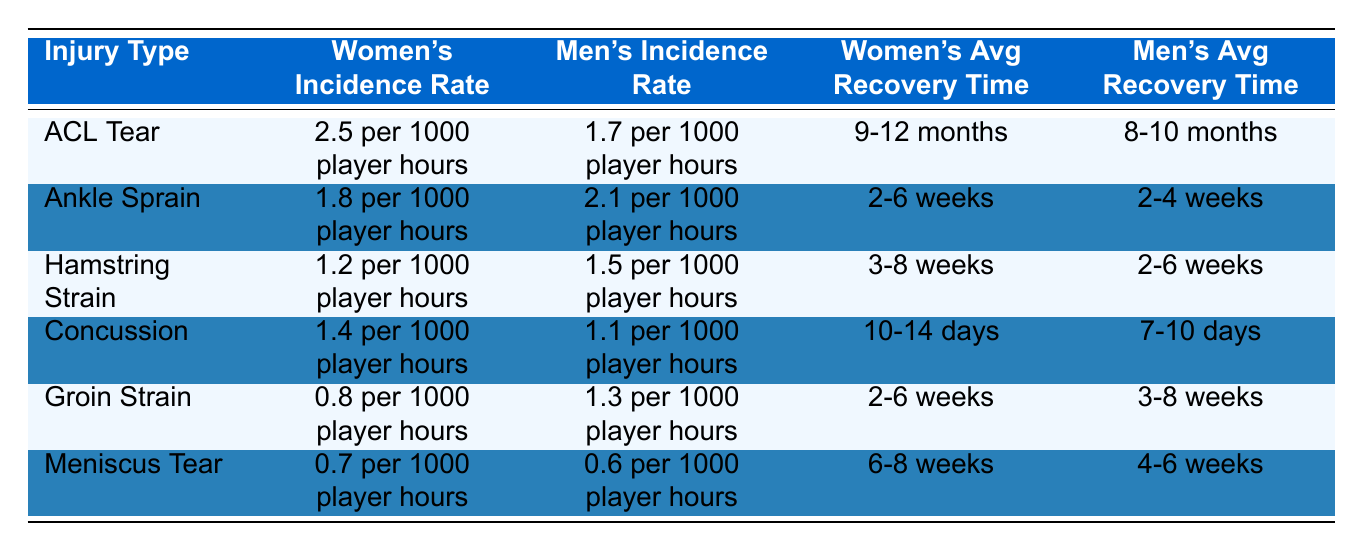What's the incidence rate of ACL tears in women's football? According to the table, the incidence rate of ACL tears for women is 2.5 per 1000 player hours.
Answer: 2.5 per 1000 player hours How does the incidence rate of ankle sprains in men's football compare to women's football? The table shows that the incidence rate of ankle sprains for men is 2.1 per 1000 player hours, while for women it is 1.8 per 1000 player hours. Men have a higher incidence rate.
Answer: Men's football has a higher incidence rate What is the average recovery time for hamstring strains in women's football? The table indicates that the average recovery time for hamstring strains in women is 3-8 weeks.
Answer: 3-8 weeks Is the average recovery time for concussions shorter in men's football than in women's football? According to the table, the average recovery time for concussions in men is 7-10 days, while for women it is 10-14 days. Therefore, men's recovery time is shorter.
Answer: Yes What is the difference in the incidence rates of meniscus tears between women's and men's football? Women's incidence rate of meniscus tears is 0.7 per 1000 player hours, and men's incidence rate is 0.6 per 1000 player hours. The difference is 0.1 per 1000 player hours, with women having a higher rate.
Answer: 0.1 per 1000 player hours Which injury has the highest average recovery time for women? From the table, the injury with the highest average recovery time for women is ACL Tear, which has a recovery time of 9-12 months.
Answer: ACL Tear Are concussions more common in women's teams compared to men's teams? The incidence rate of concussions is 1.4 per 1000 player hours for women and 1.1 per 1000 player hours for men, indicating that concussions are more common in women's teams.
Answer: Yes What is the average incidence rate for groin strains in men's football compared to women’s football? The incidence rate for groin strains in women is 0.8 per 1000 player hours, while for men it is 1.3 per 1000 player hours. Thus, the average incidence rate for men is higher.
Answer: Men's football has a higher average incidence rate 